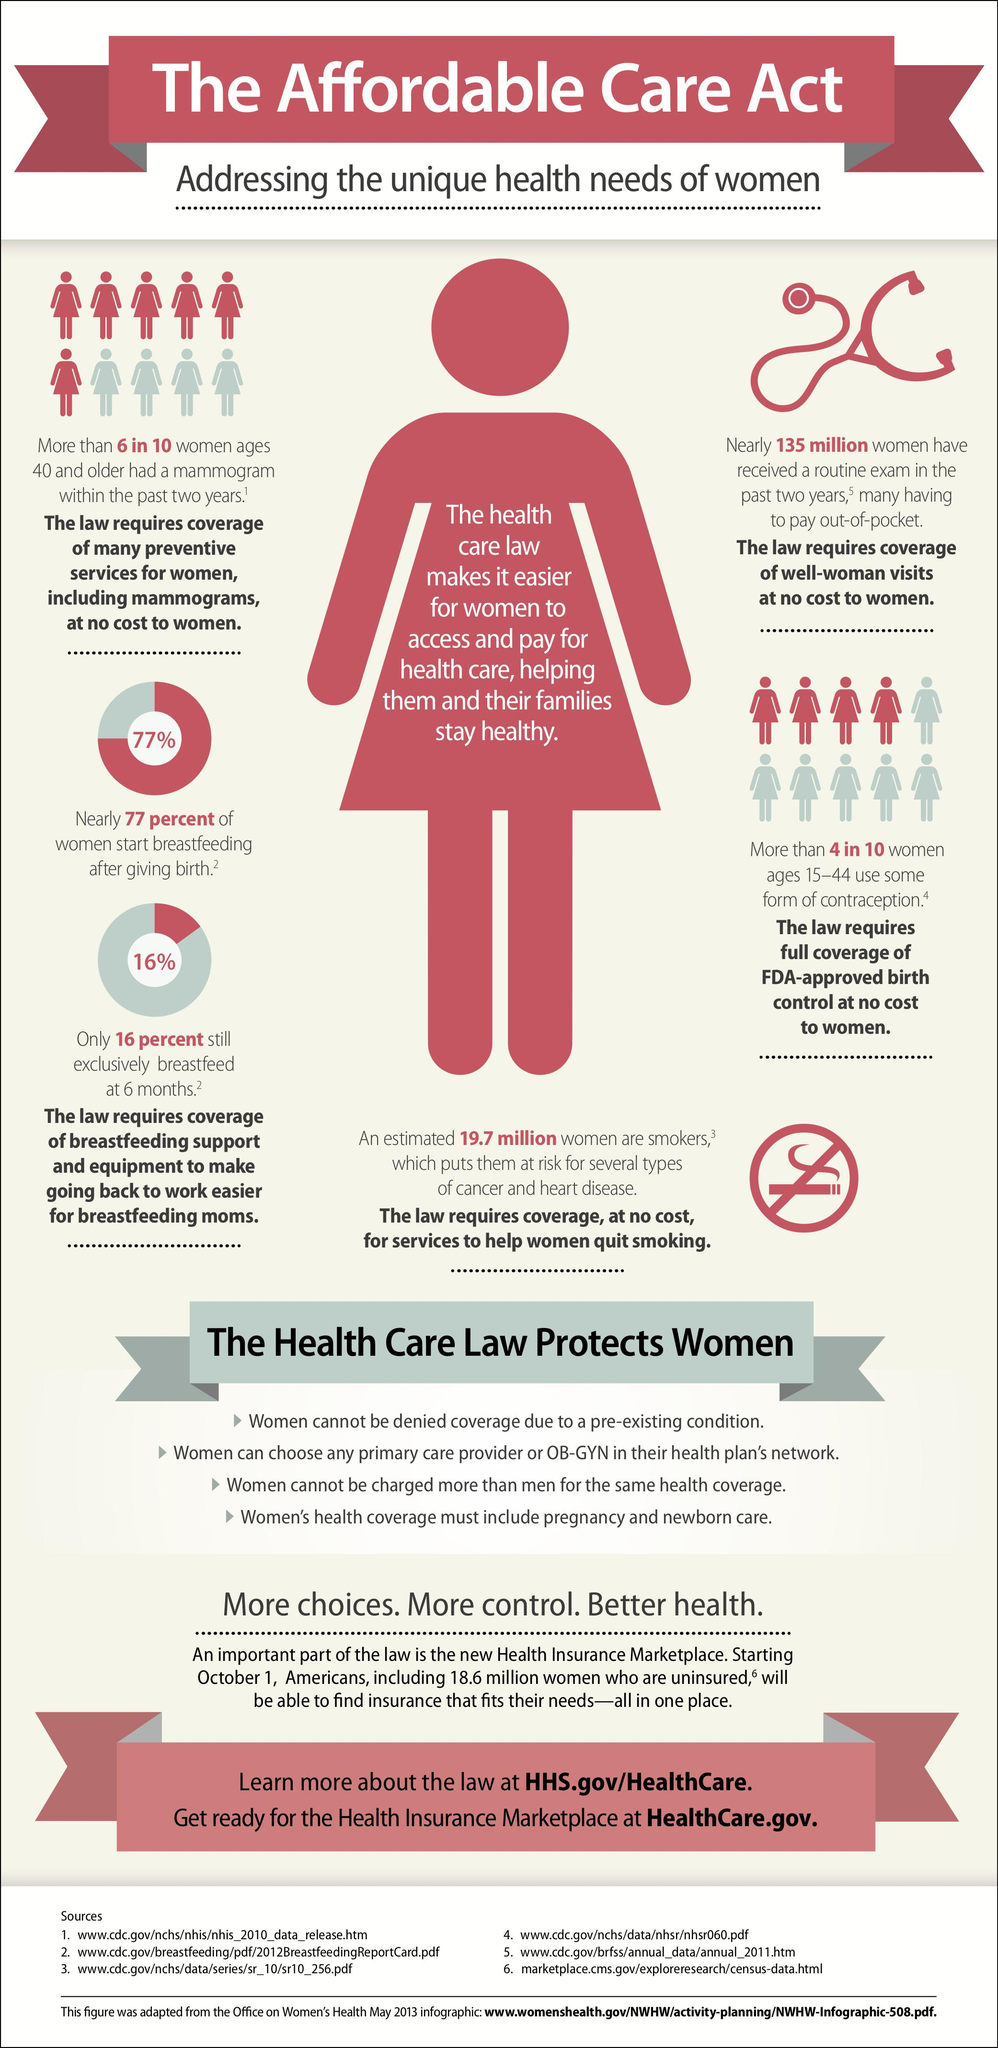Identify some key points in this picture. According to statistics, 23% of women have not started breastfeeding after giving birth. 